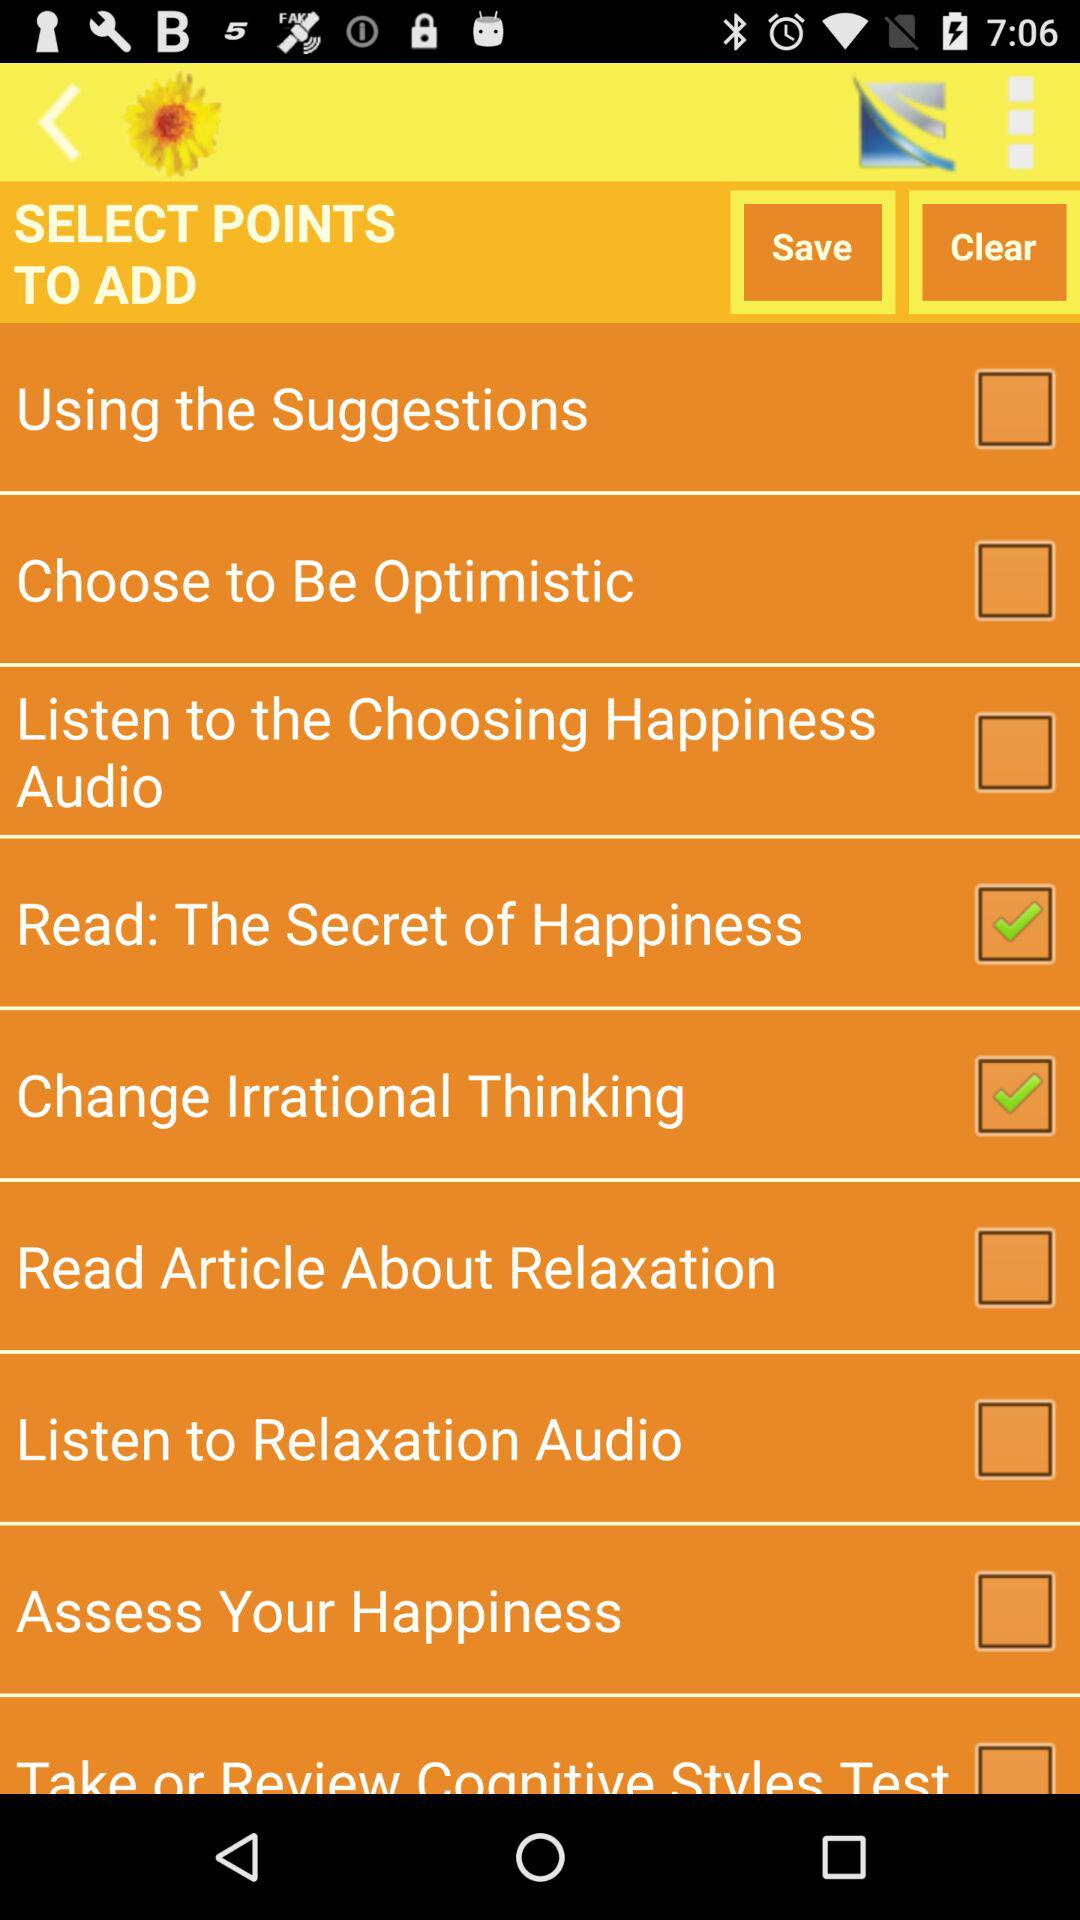What is the status of "Assess Your Happiness"? The status is off. 